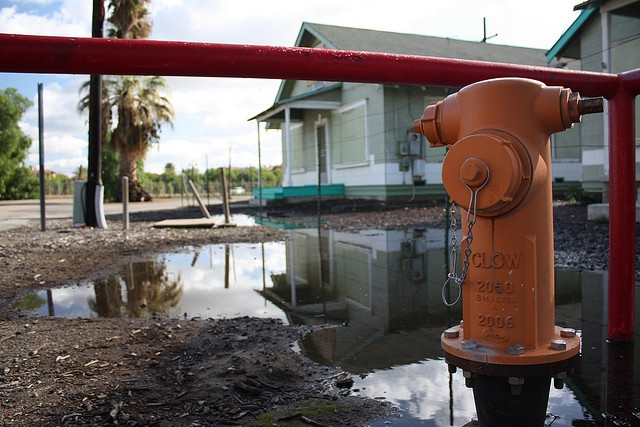Describe the objects in this image and their specific colors. I can see a fire hydrant in darkgray, maroon, black, and brown tones in this image. 